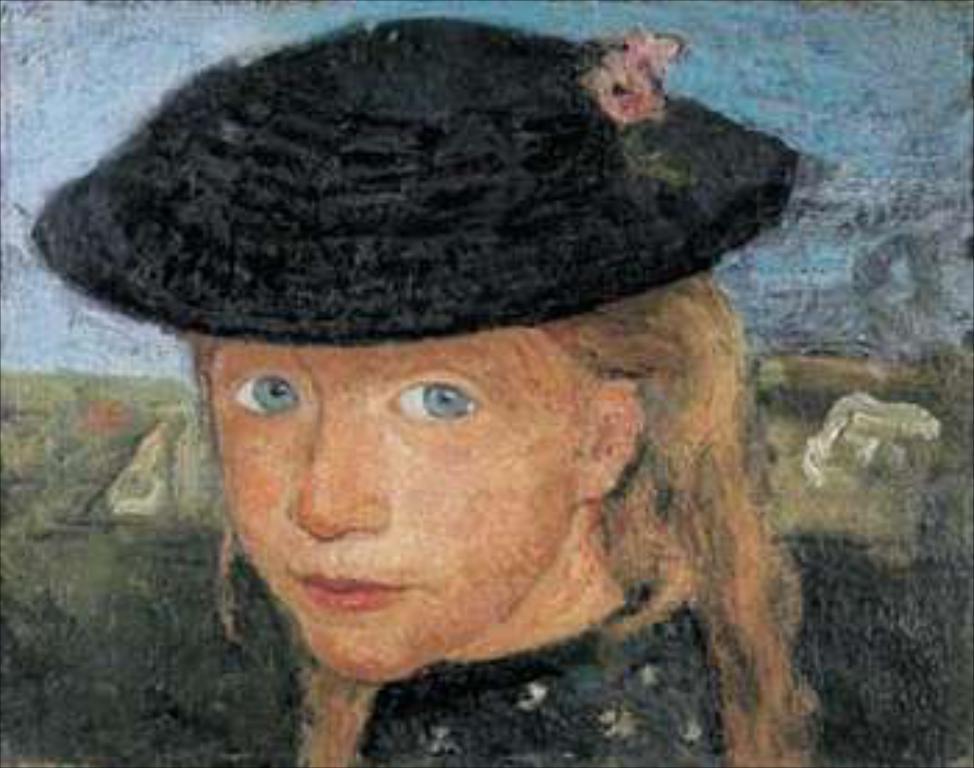Please provide a concise description of this image. In this picture we can see a painting of a girl wore a cap and in the background we can see the sky. 